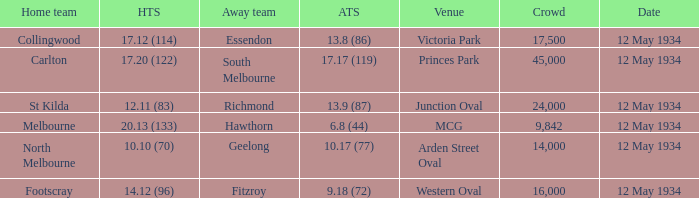Write the full table. {'header': ['Home team', 'HTS', 'Away team', 'ATS', 'Venue', 'Crowd', 'Date'], 'rows': [['Collingwood', '17.12 (114)', 'Essendon', '13.8 (86)', 'Victoria Park', '17,500', '12 May 1934'], ['Carlton', '17.20 (122)', 'South Melbourne', '17.17 (119)', 'Princes Park', '45,000', '12 May 1934'], ['St Kilda', '12.11 (83)', 'Richmond', '13.9 (87)', 'Junction Oval', '24,000', '12 May 1934'], ['Melbourne', '20.13 (133)', 'Hawthorn', '6.8 (44)', 'MCG', '9,842', '12 May 1934'], ['North Melbourne', '10.10 (70)', 'Geelong', '10.17 (77)', 'Arden Street Oval', '14,000', '12 May 1934'], ['Footscray', '14.12 (96)', 'Fitzroy', '9.18 (72)', 'Western Oval', '16,000', '12 May 1934']]} What place had an Away team get a score of 10.17 (77)? Arden Street Oval. 